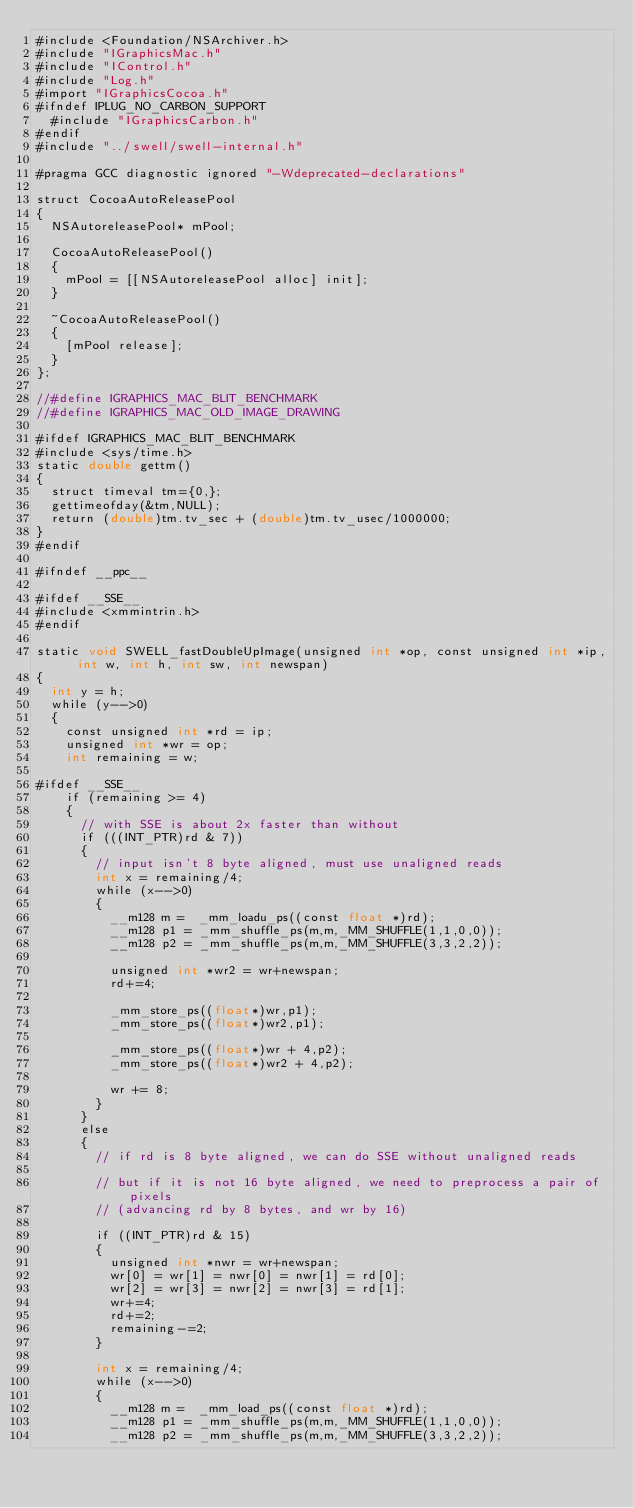<code> <loc_0><loc_0><loc_500><loc_500><_ObjectiveC_>#include <Foundation/NSArchiver.h>
#include "IGraphicsMac.h"
#include "IControl.h"
#include "Log.h"
#import "IGraphicsCocoa.h"
#ifndef IPLUG_NO_CARBON_SUPPORT
  #include "IGraphicsCarbon.h"
#endif
#include "../swell/swell-internal.h"

#pragma GCC diagnostic ignored "-Wdeprecated-declarations"

struct CocoaAutoReleasePool
{
  NSAutoreleasePool* mPool;

  CocoaAutoReleasePool()
  {
    mPool = [[NSAutoreleasePool alloc] init];
  }

  ~CocoaAutoReleasePool()
  {
    [mPool release];
  }
};

//#define IGRAPHICS_MAC_BLIT_BENCHMARK
//#define IGRAPHICS_MAC_OLD_IMAGE_DRAWING

#ifdef IGRAPHICS_MAC_BLIT_BENCHMARK
#include <sys/time.h>
static double gettm()
{
  struct timeval tm={0,};
  gettimeofday(&tm,NULL);
  return (double)tm.tv_sec + (double)tm.tv_usec/1000000;
}
#endif

#ifndef __ppc__

#ifdef __SSE__
#include <xmmintrin.h>
#endif

static void SWELL_fastDoubleUpImage(unsigned int *op, const unsigned int *ip, int w, int h, int sw, int newspan)
{
  int y = h;
  while (y-->0)
  {
    const unsigned int *rd = ip;
    unsigned int *wr = op;
    int remaining = w;
    
#ifdef __SSE__
    if (remaining >= 4)
    {
      // with SSE is about 2x faster than without
      if (((INT_PTR)rd & 7))
      {
        // input isn't 8 byte aligned, must use unaligned reads
        int x = remaining/4;
        while (x-->0)
        {
          __m128 m =  _mm_loadu_ps((const float *)rd);
          __m128 p1 = _mm_shuffle_ps(m,m,_MM_SHUFFLE(1,1,0,0));
          __m128 p2 = _mm_shuffle_ps(m,m,_MM_SHUFFLE(3,3,2,2));
          
          unsigned int *wr2 = wr+newspan;
          rd+=4;
          
          _mm_store_ps((float*)wr,p1);
          _mm_store_ps((float*)wr2,p1);
          
          _mm_store_ps((float*)wr + 4,p2);
          _mm_store_ps((float*)wr2 + 4,p2);
          
          wr += 8;
        }
      }
      else
      {
        // if rd is 8 byte aligned, we can do SSE without unaligned reads
        
        // but if it is not 16 byte aligned, we need to preprocess a pair of pixels
        // (advancing rd by 8 bytes, and wr by 16)
        
        if ((INT_PTR)rd & 15)
        {
          unsigned int *nwr = wr+newspan;
          wr[0] = wr[1] = nwr[0] = nwr[1] = rd[0];
          wr[2] = wr[3] = nwr[2] = nwr[3] = rd[1];
          wr+=4;
          rd+=2;
          remaining-=2;
        }
        
        int x = remaining/4;
        while (x-->0)
        {
          __m128 m =  _mm_load_ps((const float *)rd);
          __m128 p1 = _mm_shuffle_ps(m,m,_MM_SHUFFLE(1,1,0,0));
          __m128 p2 = _mm_shuffle_ps(m,m,_MM_SHUFFLE(3,3,2,2));
          </code> 